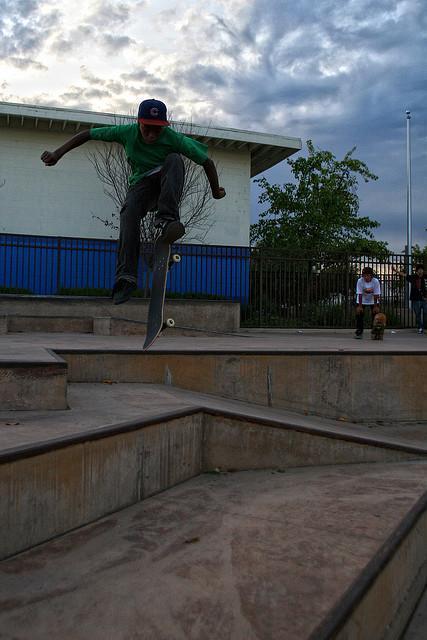How many people at the table are wearing tie dye?
Give a very brief answer. 0. 